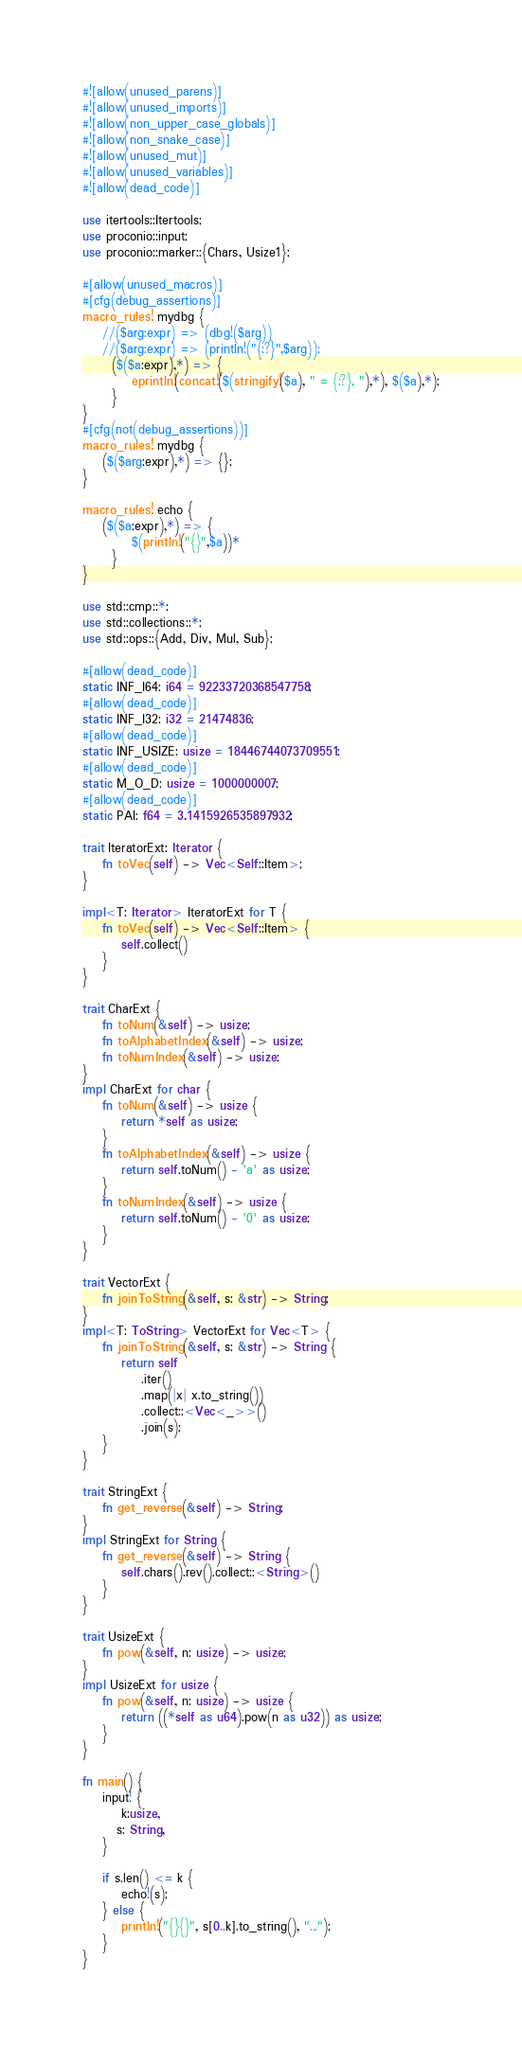<code> <loc_0><loc_0><loc_500><loc_500><_Rust_>#![allow(unused_parens)]
#![allow(unused_imports)]
#![allow(non_upper_case_globals)]
#![allow(non_snake_case)]
#![allow(unused_mut)]
#![allow(unused_variables)]
#![allow(dead_code)]

use itertools::Itertools;
use proconio::input;
use proconio::marker::{Chars, Usize1};

#[allow(unused_macros)]
#[cfg(debug_assertions)]
macro_rules! mydbg {
    //($arg:expr) => (dbg!($arg))
    //($arg:expr) => (println!("{:?}",$arg));
      ($($a:expr),*) => {
          eprintln!(concat!($(stringify!($a), " = {:?}, "),*), $($a),*);
      }
}
#[cfg(not(debug_assertions))]
macro_rules! mydbg {
    ($($arg:expr),*) => {};
}

macro_rules! echo {
    ($($a:expr),*) => {
          $(println!("{}",$a))*
      }
}

use std::cmp::*;
use std::collections::*;
use std::ops::{Add, Div, Mul, Sub};

#[allow(dead_code)]
static INF_I64: i64 = 92233720368547758;
#[allow(dead_code)]
static INF_I32: i32 = 21474836;
#[allow(dead_code)]
static INF_USIZE: usize = 18446744073709551;
#[allow(dead_code)]
static M_O_D: usize = 1000000007;
#[allow(dead_code)]
static PAI: f64 = 3.1415926535897932;

trait IteratorExt: Iterator {
    fn toVec(self) -> Vec<Self::Item>;
}

impl<T: Iterator> IteratorExt for T {
    fn toVec(self) -> Vec<Self::Item> {
        self.collect()
    }
}

trait CharExt {
    fn toNum(&self) -> usize;
    fn toAlphabetIndex(&self) -> usize;
    fn toNumIndex(&self) -> usize;
}
impl CharExt for char {
    fn toNum(&self) -> usize {
        return *self as usize;
    }
    fn toAlphabetIndex(&self) -> usize {
        return self.toNum() - 'a' as usize;
    }
    fn toNumIndex(&self) -> usize {
        return self.toNum() - '0' as usize;
    }
}

trait VectorExt {
    fn joinToString(&self, s: &str) -> String;
}
impl<T: ToString> VectorExt for Vec<T> {
    fn joinToString(&self, s: &str) -> String {
        return self
            .iter()
            .map(|x| x.to_string())
            .collect::<Vec<_>>()
            .join(s);
    }
}

trait StringExt {
    fn get_reverse(&self) -> String;
}
impl StringExt for String {
    fn get_reverse(&self) -> String {
        self.chars().rev().collect::<String>()
    }
}

trait UsizeExt {
    fn pow(&self, n: usize) -> usize;
}
impl UsizeExt for usize {
    fn pow(&self, n: usize) -> usize {
        return ((*self as u64).pow(n as u32)) as usize;
    }
}

fn main() {
    input! {
        k:usize,
       s: String,
    }

    if s.len() <= k {
        echo!(s);
    } else {
        println!("{}{}", s[0..k].to_string(), "...");
    }
}
</code> 